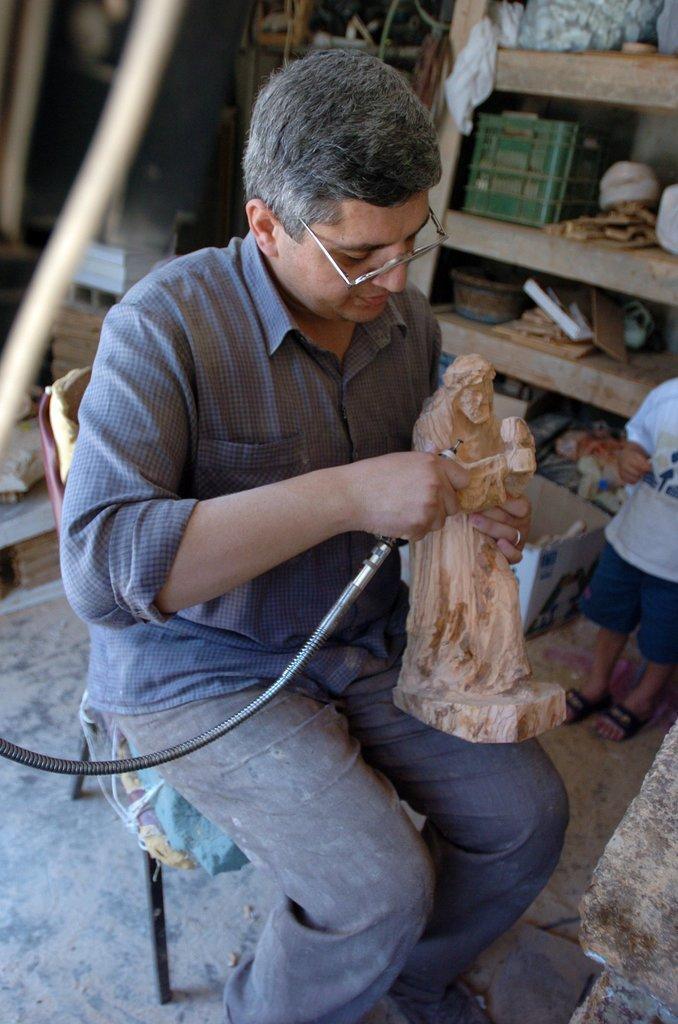Describe this image in one or two sentences. This man is sitting on a chair, holding a wooden sculpture and an object. In that rock there are things. On the floor there is a cardboard box and things. Here we can see a kid.  